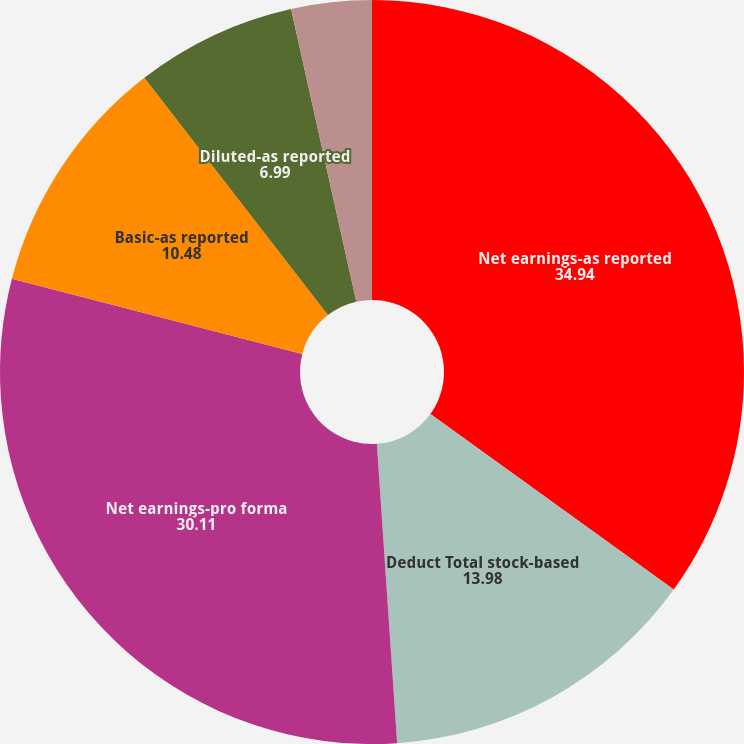Convert chart to OTSL. <chart><loc_0><loc_0><loc_500><loc_500><pie_chart><fcel>Net earnings-as reported<fcel>Deduct Total stock-based<fcel>Net earnings-pro forma<fcel>Basic-as reported<fcel>Diluted-as reported<fcel>Basic-pro forma<fcel>Diluted-proforma<nl><fcel>34.94%<fcel>13.98%<fcel>30.11%<fcel>10.48%<fcel>6.99%<fcel>3.49%<fcel>0.0%<nl></chart> 